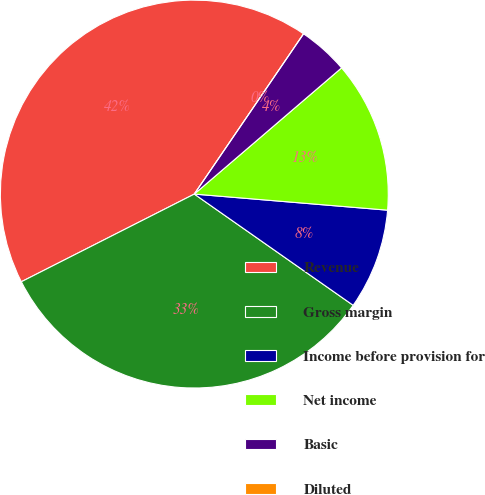<chart> <loc_0><loc_0><loc_500><loc_500><pie_chart><fcel>Revenue<fcel>Gross margin<fcel>Income before provision for<fcel>Net income<fcel>Basic<fcel>Diluted<nl><fcel>41.99%<fcel>32.81%<fcel>8.4%<fcel>12.6%<fcel>4.2%<fcel>0.0%<nl></chart> 